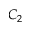Convert formula to latex. <formula><loc_0><loc_0><loc_500><loc_500>C _ { 2 }</formula> 